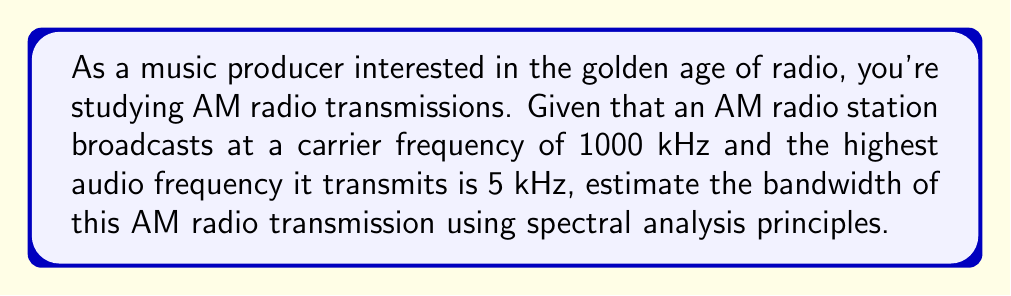Provide a solution to this math problem. To estimate the bandwidth of an AM radio transmission, we need to consider the following steps:

1. Understand AM modulation:
   AM (Amplitude Modulation) works by varying the amplitude of a high-frequency carrier signal based on the amplitude of the audio signal.

2. Identify key components:
   - Carrier frequency: $f_c = 1000$ kHz
   - Highest audio frequency: $f_m = 5$ kHz

3. Apply spectral analysis:
   In AM, the modulated signal's spectrum consists of:
   - The carrier frequency
   - Two sidebands: upper and lower

4. Calculate bandwidth:
   For AM, the bandwidth is given by:
   
   $$ B = 2f_m $$
   
   Where $B$ is the bandwidth and $f_m$ is the highest modulating frequency.

5. Substitute values:
   $$ B = 2 \times 5 \text{ kHz} = 10 \text{ kHz} $$

This bandwidth ensures that all significant frequency components of the modulated signal are transmitted, including the carrier and both sidebands.
Answer: 10 kHz 